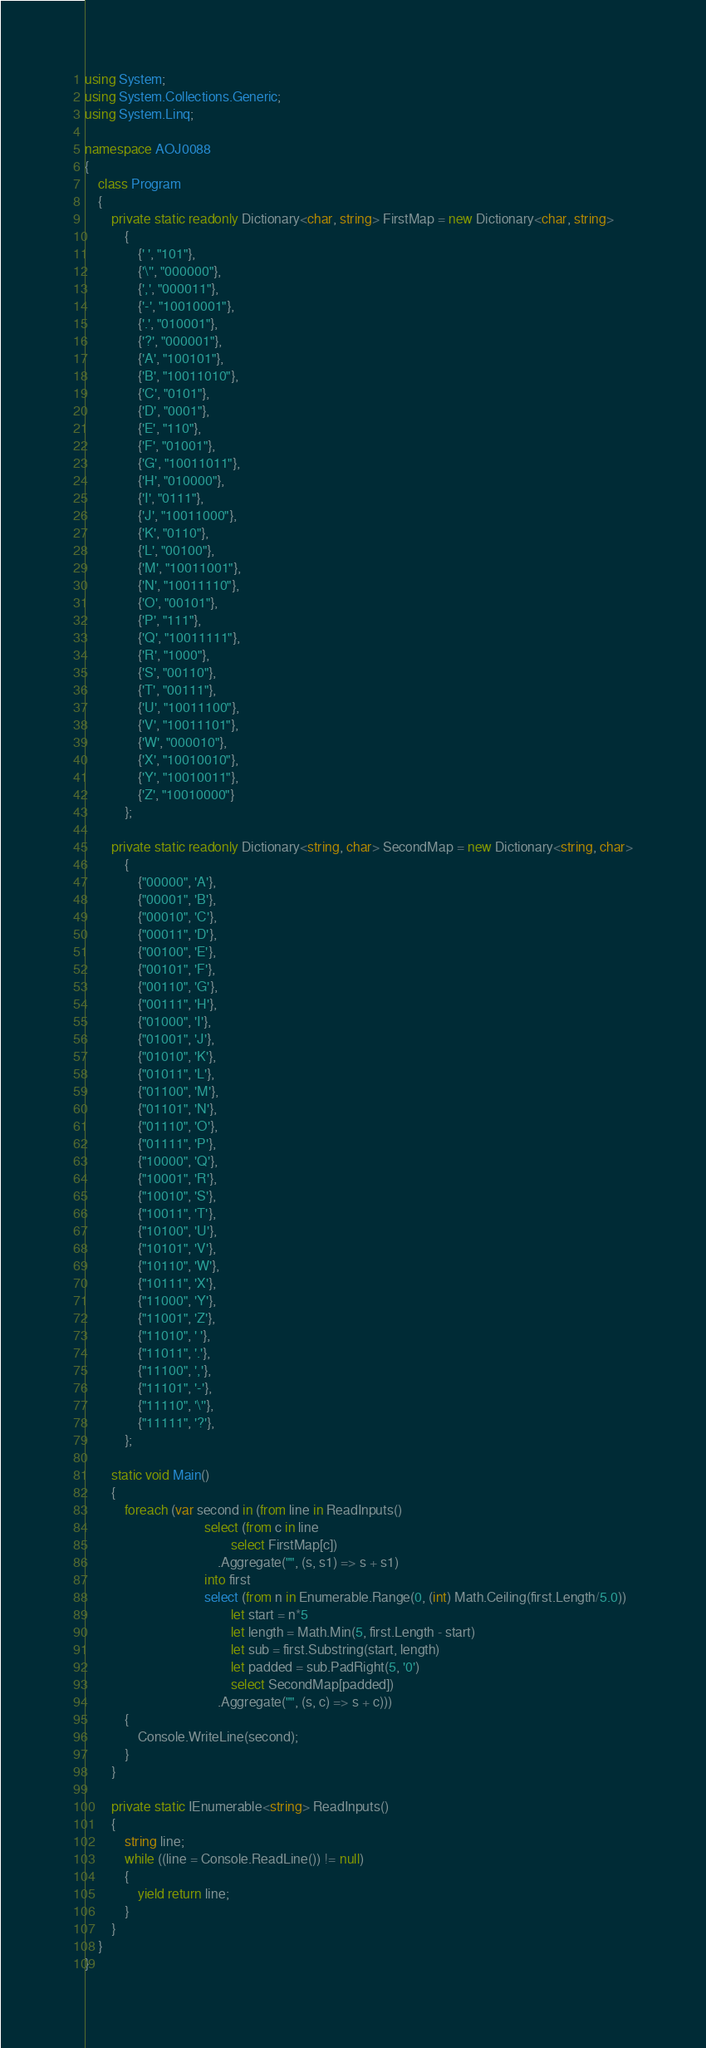Convert code to text. <code><loc_0><loc_0><loc_500><loc_500><_C#_>using System;
using System.Collections.Generic;
using System.Linq;

namespace AOJ0088
{
    class Program
    {
        private static readonly Dictionary<char, string> FirstMap = new Dictionary<char, string>
            {
                {' ', "101"},
                {'\'', "000000"},
                {',', "000011"},
                {'-', "10010001"},
                {'.', "010001"},
                {'?', "000001"},
                {'A', "100101"},
                {'B', "10011010"},
                {'C', "0101"},
                {'D', "0001"},
                {'E', "110"},
                {'F', "01001"},
                {'G', "10011011"},
                {'H', "010000"},
                {'I', "0111"},
                {'J', "10011000"},
                {'K', "0110"},
                {'L', "00100"},
                {'M', "10011001"},
                {'N', "10011110"},
                {'O', "00101"},
                {'P', "111"},
                {'Q', "10011111"},
                {'R', "1000"},
                {'S', "00110"},
                {'T', "00111"},
                {'U', "10011100"},
                {'V', "10011101"},
                {'W', "000010"},
                {'X', "10010010"},
                {'Y', "10010011"},
                {'Z', "10010000"}
            };

        private static readonly Dictionary<string, char> SecondMap = new Dictionary<string, char>
            {
                {"00000", 'A'},
                {"00001", 'B'},
                {"00010", 'C'},
                {"00011", 'D'},
                {"00100", 'E'},
                {"00101", 'F'},
                {"00110", 'G'},
                {"00111", 'H'},
                {"01000", 'I'},
                {"01001", 'J'},
                {"01010", 'K'},
                {"01011", 'L'},
                {"01100", 'M'},
                {"01101", 'N'},
                {"01110", 'O'},
                {"01111", 'P'},
                {"10000", 'Q'},
                {"10001", 'R'},
                {"10010", 'S'},
                {"10011", 'T'},
                {"10100", 'U'},
                {"10101", 'V'},
                {"10110", 'W'},
                {"10111", 'X'},
                {"11000", 'Y'},
                {"11001", 'Z'},
                {"11010", ' '},
                {"11011", '.'},
                {"11100", ','},
                {"11101", '-'},
                {"11110", '\''},
                {"11111", '?'},
            };

        static void Main()
        {
            foreach (var second in (from line in ReadInputs()
                                    select (from c in line
                                            select FirstMap[c])
                                        .Aggregate("", (s, s1) => s + s1)
                                    into first
                                    select (from n in Enumerable.Range(0, (int) Math.Ceiling(first.Length/5.0))
                                            let start = n*5
                                            let length = Math.Min(5, first.Length - start)
                                            let sub = first.Substring(start, length)
                                            let padded = sub.PadRight(5, '0')
                                            select SecondMap[padded])
                                        .Aggregate("", (s, c) => s + c)))
            {
                Console.WriteLine(second);
            }
        }

        private static IEnumerable<string> ReadInputs()
        {
            string line;
            while ((line = Console.ReadLine()) != null)
            {
                yield return line;
            }
        }
    }
}</code> 